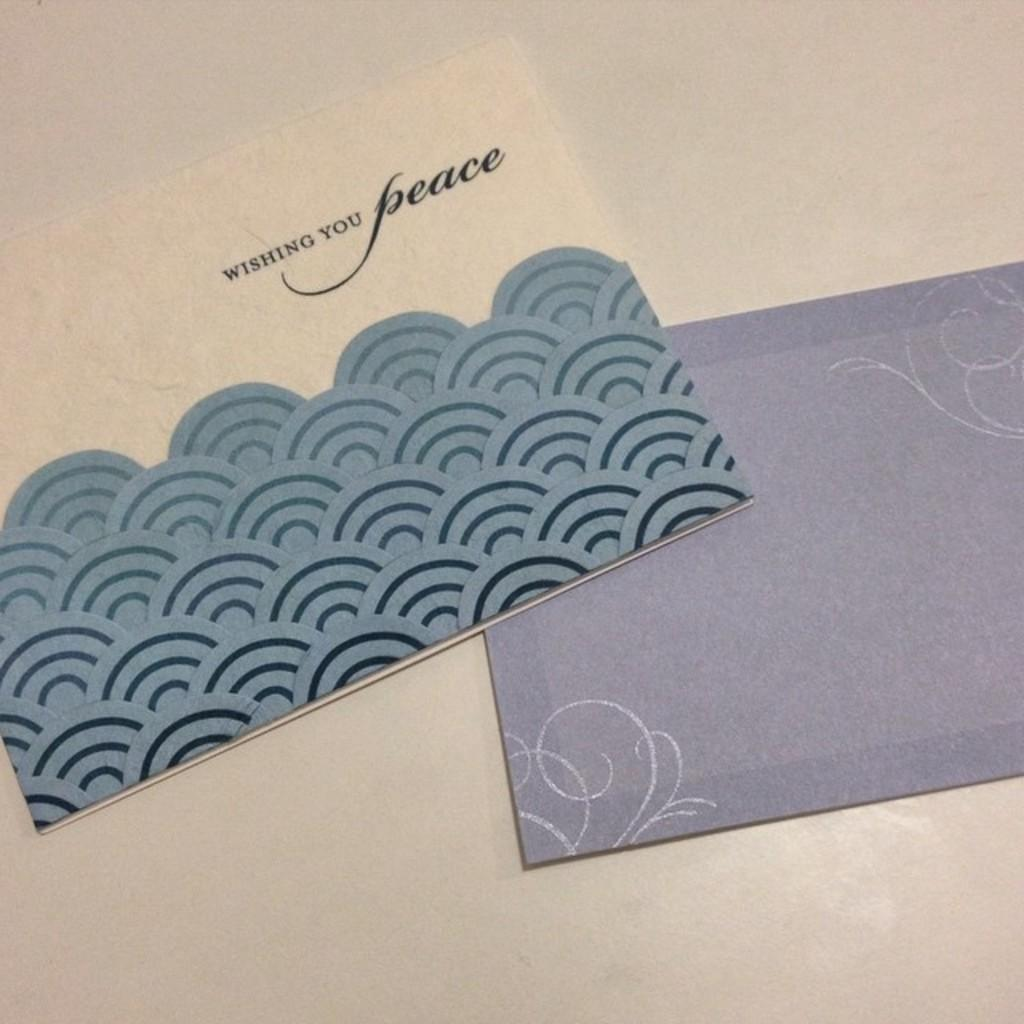<image>
Share a concise interpretation of the image provided. A sympathy card says "wishing you peace" on the front. 